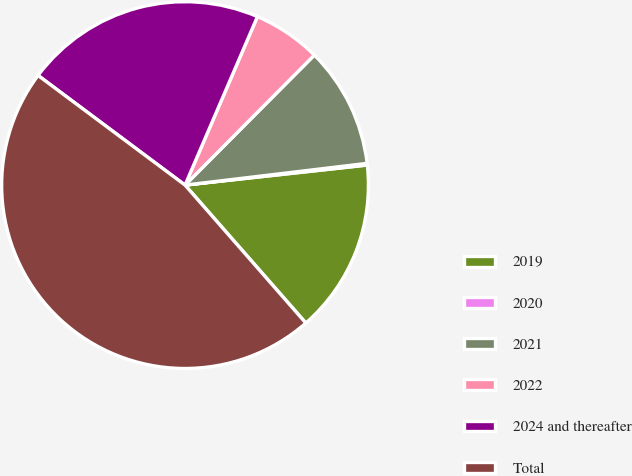Convert chart. <chart><loc_0><loc_0><loc_500><loc_500><pie_chart><fcel>2019<fcel>2020<fcel>2021<fcel>2022<fcel>2024 and thereafter<fcel>Total<nl><fcel>15.3%<fcel>0.15%<fcel>10.65%<fcel>6.0%<fcel>21.26%<fcel>46.65%<nl></chart> 